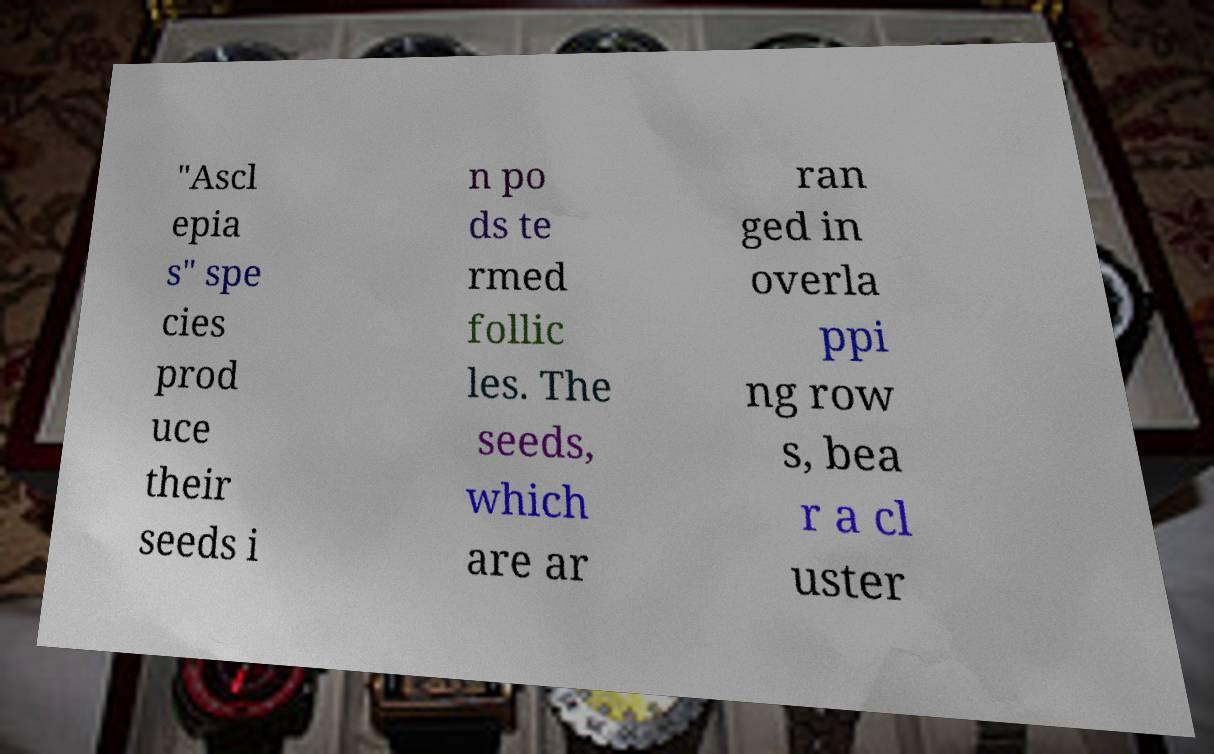What messages or text are displayed in this image? I need them in a readable, typed format. "Ascl epia s" spe cies prod uce their seeds i n po ds te rmed follic les. The seeds, which are ar ran ged in overla ppi ng row s, bea r a cl uster 